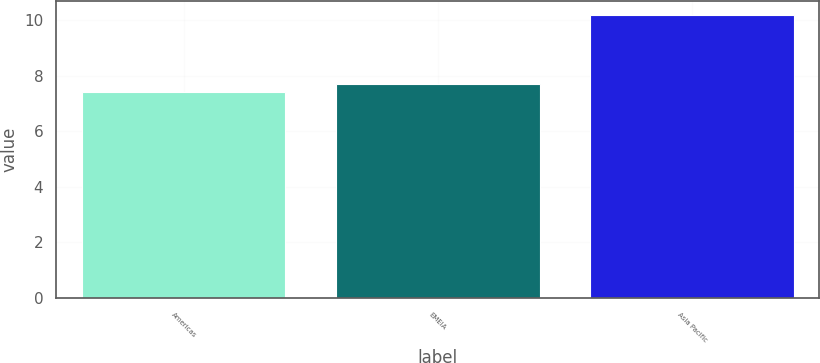Convert chart to OTSL. <chart><loc_0><loc_0><loc_500><loc_500><bar_chart><fcel>Americas<fcel>EMEIA<fcel>Asia Pacific<nl><fcel>7.4<fcel>7.7<fcel>10.2<nl></chart> 